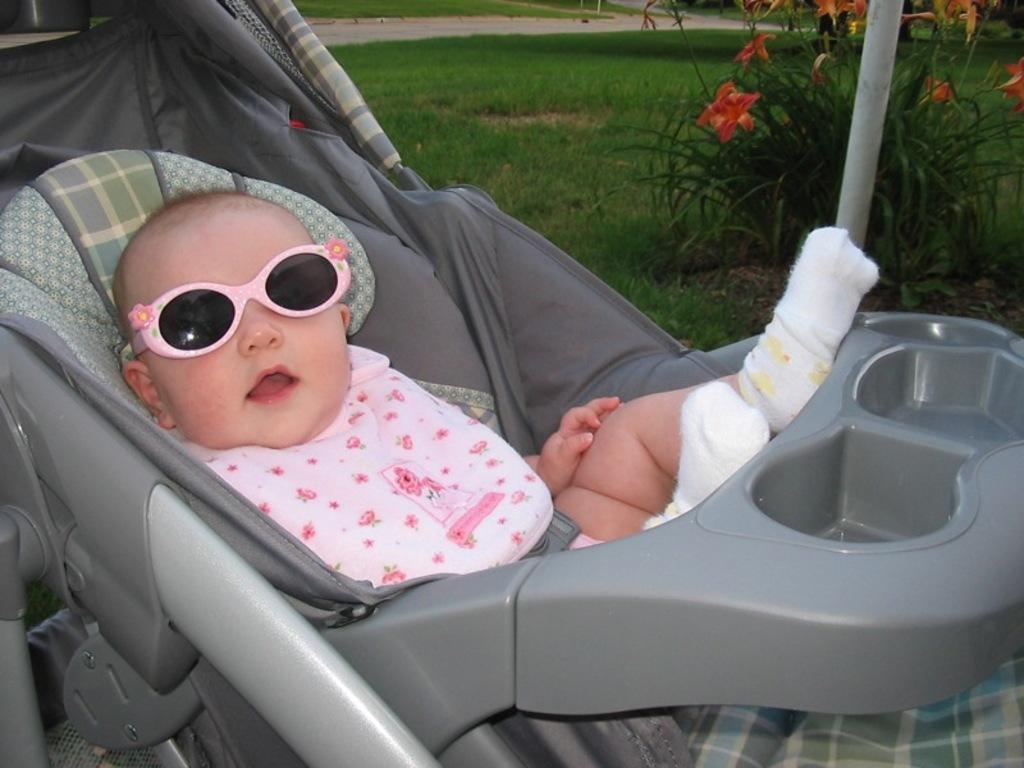What can be seen in the image that is used for transporting a baby? There is a stroller in the image that is used for transporting a baby. What is the baby in the stroller wearing? The baby is wearing goggles and socks. Where is the plant located in the image? The plant is in the top right corner of the image. What is the baby's income in the image? The baby's income cannot be determined from the image, as babies do not have income. 